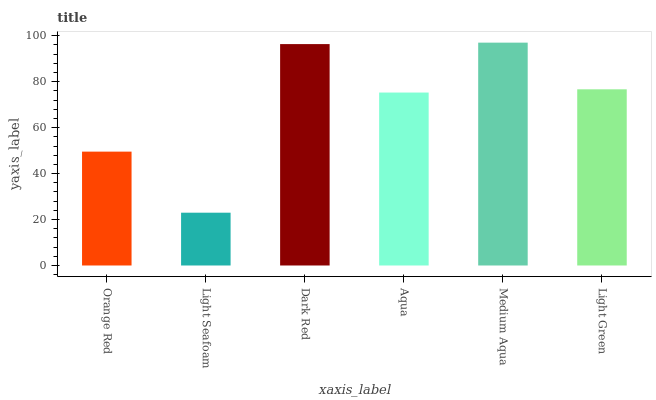Is Light Seafoam the minimum?
Answer yes or no. Yes. Is Medium Aqua the maximum?
Answer yes or no. Yes. Is Dark Red the minimum?
Answer yes or no. No. Is Dark Red the maximum?
Answer yes or no. No. Is Dark Red greater than Light Seafoam?
Answer yes or no. Yes. Is Light Seafoam less than Dark Red?
Answer yes or no. Yes. Is Light Seafoam greater than Dark Red?
Answer yes or no. No. Is Dark Red less than Light Seafoam?
Answer yes or no. No. Is Light Green the high median?
Answer yes or no. Yes. Is Aqua the low median?
Answer yes or no. Yes. Is Dark Red the high median?
Answer yes or no. No. Is Dark Red the low median?
Answer yes or no. No. 